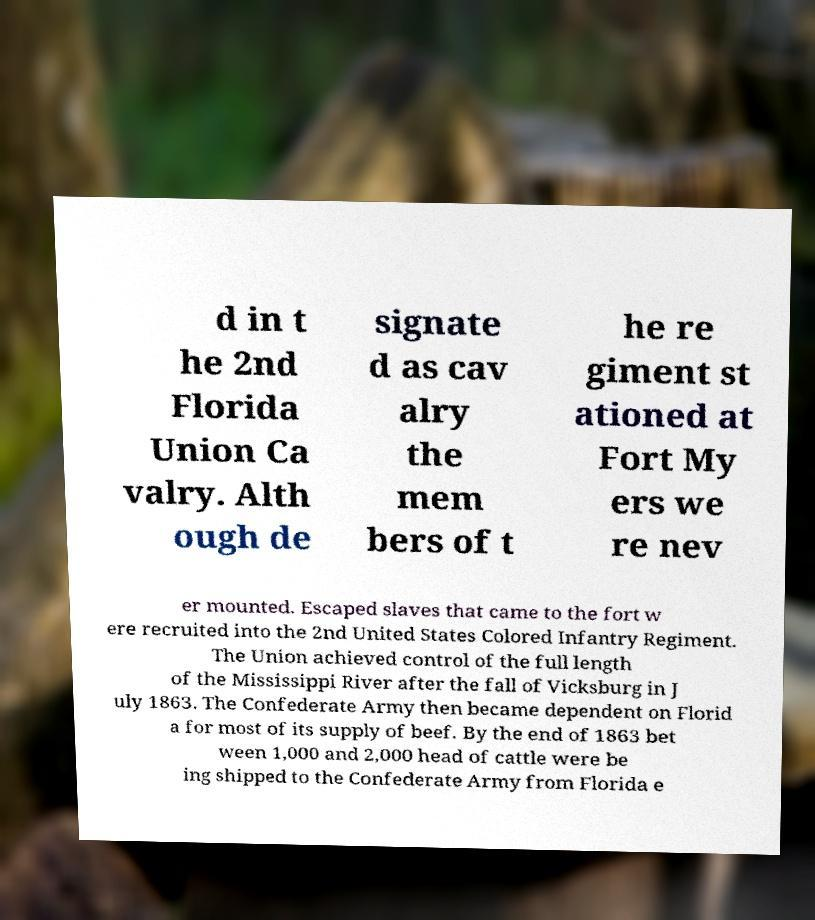I need the written content from this picture converted into text. Can you do that? d in t he 2nd Florida Union Ca valry. Alth ough de signate d as cav alry the mem bers of t he re giment st ationed at Fort My ers we re nev er mounted. Escaped slaves that came to the fort w ere recruited into the 2nd United States Colored Infantry Regiment. The Union achieved control of the full length of the Mississippi River after the fall of Vicksburg in J uly 1863. The Confederate Army then became dependent on Florid a for most of its supply of beef. By the end of 1863 bet ween 1,000 and 2,000 head of cattle were be ing shipped to the Confederate Army from Florida e 